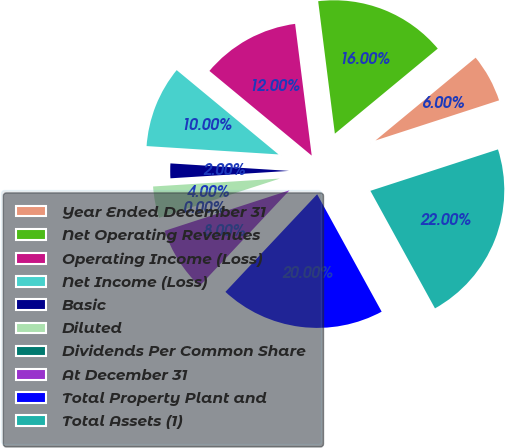<chart> <loc_0><loc_0><loc_500><loc_500><pie_chart><fcel>Year Ended December 31<fcel>Net Operating Revenues<fcel>Operating Income (Loss)<fcel>Net Income (Loss)<fcel>Basic<fcel>Diluted<fcel>Dividends Per Common Share<fcel>At December 31<fcel>Total Property Plant and<fcel>Total Assets (1)<nl><fcel>6.0%<fcel>16.0%<fcel>12.0%<fcel>10.0%<fcel>2.0%<fcel>4.0%<fcel>0.0%<fcel>8.0%<fcel>20.0%<fcel>22.0%<nl></chart> 